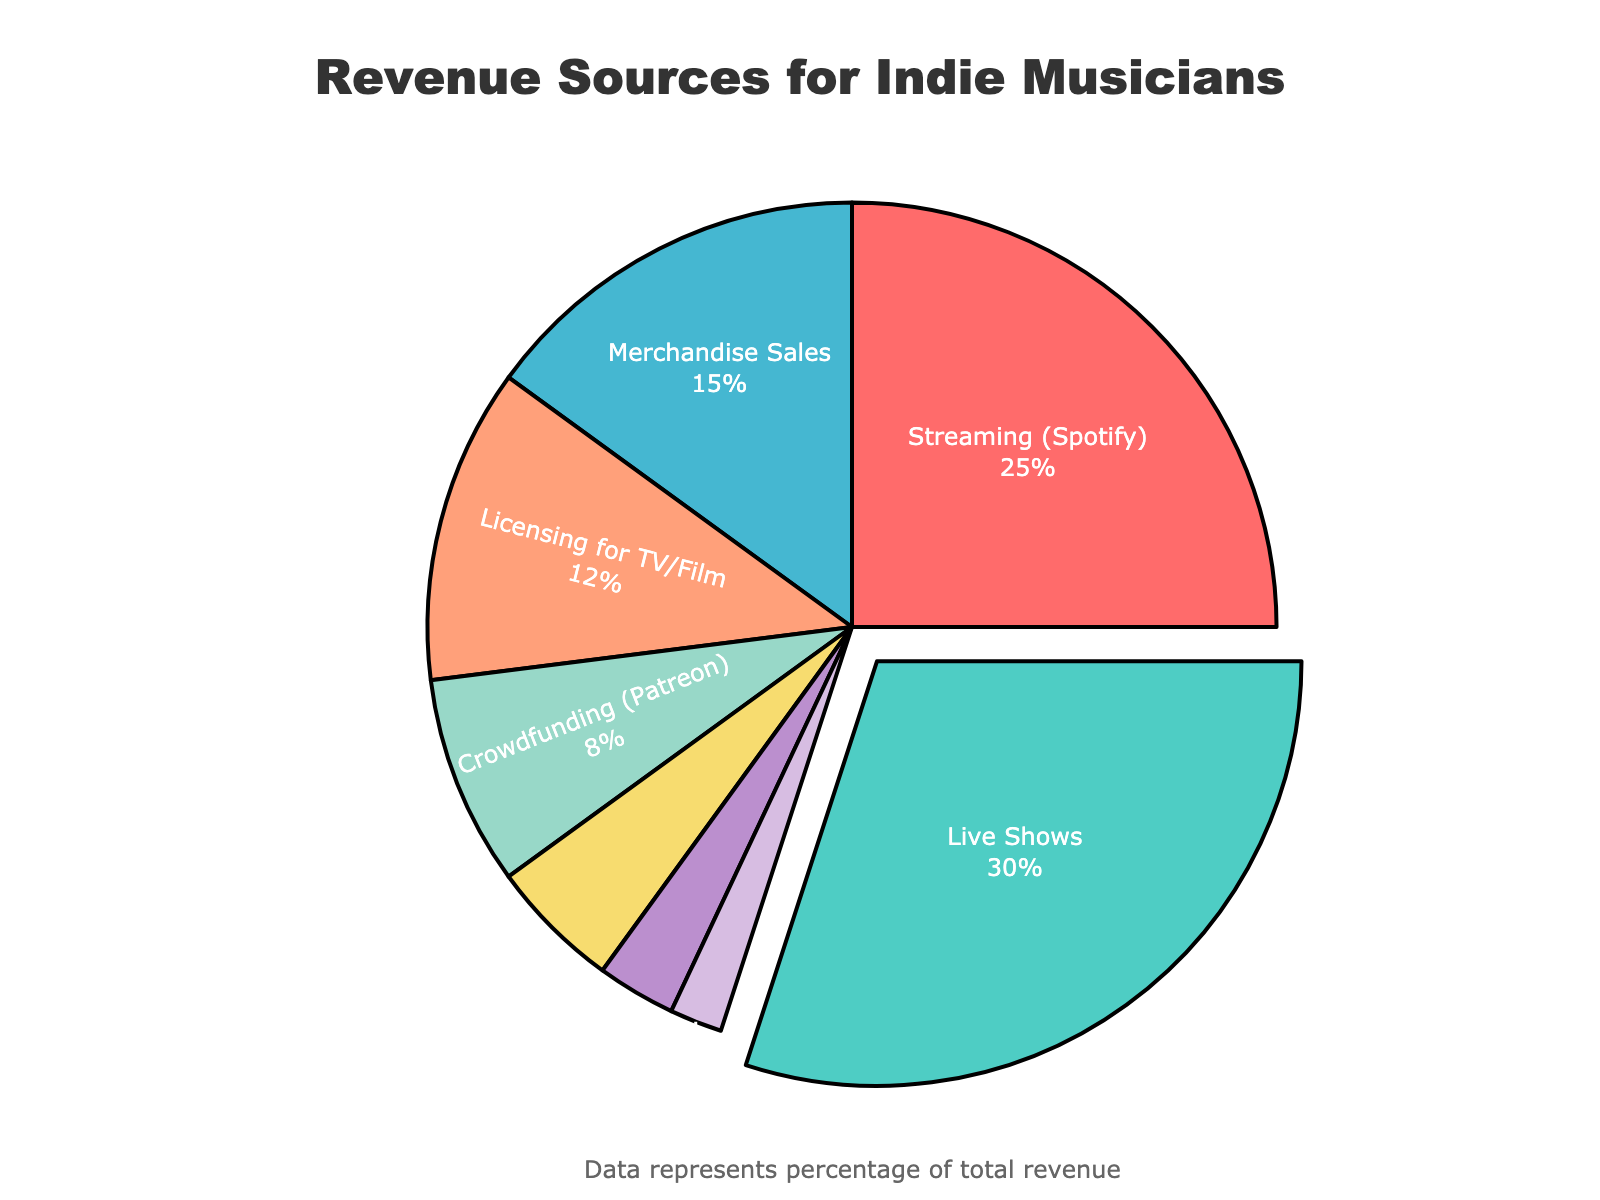Which revenue source contributes the most to indie musicians' overall revenue? By looking at the pie chart, the largest segment can be identified, which in this case represents "Live Shows" with 30%.
Answer: Live Shows How much more does streaming revenue contribute compared to physical album sales? The pie chart shows 25% for Streaming and 3% for Physical Album Sales. The difference is calculated as 25% - 3% = 22%.
Answer: 22% What's the combined percentage of revenue from Licensing for TV/Film and Sync Licensing for Commercials? Licensing for TV/Film contributes 12% and Sync Licensing for Commercials contributes 2%. Adding them up gives 12% + 2% = 14%.
Answer: 14% Which revenue source has the smallest contribution? The smallest segment in the pie chart represents "Sync Licensing for Commercials" with 2%.
Answer: Sync Licensing for Commercials Are Merchandise Sales or Crowdfunding a bigger revenue source? Merchandise Sales contribute 15% and Crowdfunding (Patreon) contributes 8%. Comparing these values shows that Merchandise Sales is bigger.
Answer: Merchandise Sales What's the total percentage of revenue from non-streaming digital sources (Digital Album Sales and Crowdfunding)? Digital Album Sales contribute 5% and Crowdfunding (Patreon) contributes 8%. Adding them gives 5% + 8% = 13%.
Answer: 13% Which revenue source contributes twice as much as Physical Album Sales? Physical Album Sales contribute 3%. The revenue source that contributes twice this amount is 3% * 2 = 6%. None in the chart, but the closest high value is "Crowdfunding (Patreon)" which contributes 8%.
Answer: Crowdfunding (Patreon) How does the contribution of Live Shows compare to the total combined contribution of Merchandise Sales and Digital Album Sales? Live Shows contribute 30%. The combined contribution of Merchandise Sales (15%) and Digital Album Sales (5%) is 15% + 5% = 20%. Comparatively, Live Shows contribute 10% more.
Answer: 10% more 